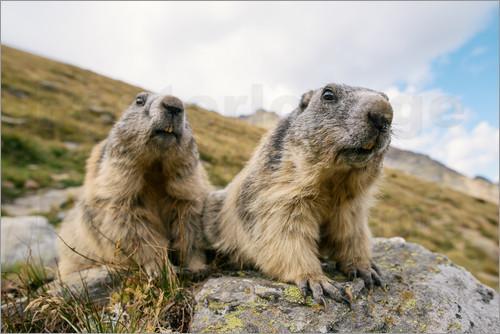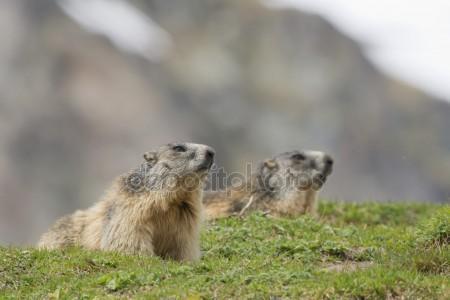The first image is the image on the left, the second image is the image on the right. For the images shown, is this caption "One of the images shows two groundhogs facing each other." true? Answer yes or no. No. The first image is the image on the left, the second image is the image on the right. For the images displayed, is the sentence "Two animals in the image in the left are sitting face to face." factually correct? Answer yes or no. No. 